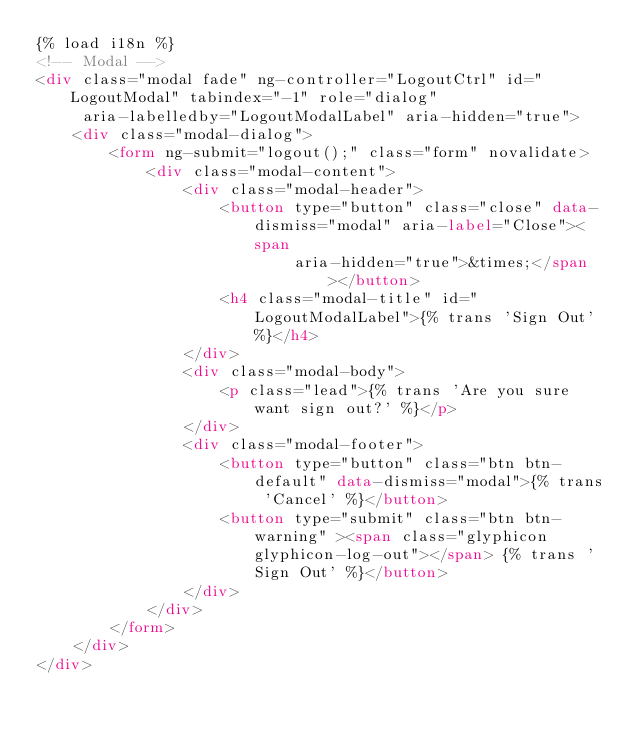Convert code to text. <code><loc_0><loc_0><loc_500><loc_500><_HTML_>{% load i18n %}
<!-- Modal -->
<div class="modal fade" ng-controller="LogoutCtrl" id="LogoutModal" tabindex="-1" role="dialog"
     aria-labelledby="LogoutModalLabel" aria-hidden="true">
    <div class="modal-dialog">
        <form ng-submit="logout();" class="form" novalidate>
            <div class="modal-content">
                <div class="modal-header">
                    <button type="button" class="close" data-dismiss="modal" aria-label="Close"><span
                            aria-hidden="true">&times;</span></button>
                    <h4 class="modal-title" id="LogoutModalLabel">{% trans 'Sign Out' %}</h4>
                </div>
                <div class="modal-body">
                    <p class="lead">{% trans 'Are you sure want sign out?' %}</p>
                </div>
                <div class="modal-footer">
                    <button type="button" class="btn btn-default" data-dismiss="modal">{% trans 'Cancel' %}</button>
                    <button type="submit" class="btn btn-warning" ><span class="glyphicon glyphicon-log-out"></span> {% trans 'Sign Out' %}</button>
                </div>
            </div>
        </form>
    </div>
</div></code> 